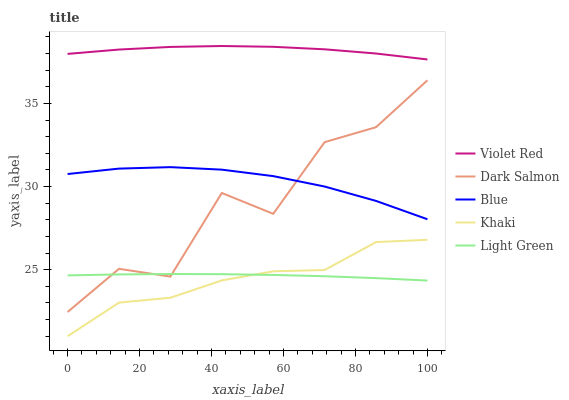Does Khaki have the minimum area under the curve?
Answer yes or no. Yes. Does Violet Red have the maximum area under the curve?
Answer yes or no. Yes. Does Violet Red have the minimum area under the curve?
Answer yes or no. No. Does Khaki have the maximum area under the curve?
Answer yes or no. No. Is Light Green the smoothest?
Answer yes or no. Yes. Is Dark Salmon the roughest?
Answer yes or no. Yes. Is Violet Red the smoothest?
Answer yes or no. No. Is Violet Red the roughest?
Answer yes or no. No. Does Khaki have the lowest value?
Answer yes or no. Yes. Does Violet Red have the lowest value?
Answer yes or no. No. Does Violet Red have the highest value?
Answer yes or no. Yes. Does Khaki have the highest value?
Answer yes or no. No. Is Blue less than Violet Red?
Answer yes or no. Yes. Is Blue greater than Light Green?
Answer yes or no. Yes. Does Dark Salmon intersect Blue?
Answer yes or no. Yes. Is Dark Salmon less than Blue?
Answer yes or no. No. Is Dark Salmon greater than Blue?
Answer yes or no. No. Does Blue intersect Violet Red?
Answer yes or no. No. 